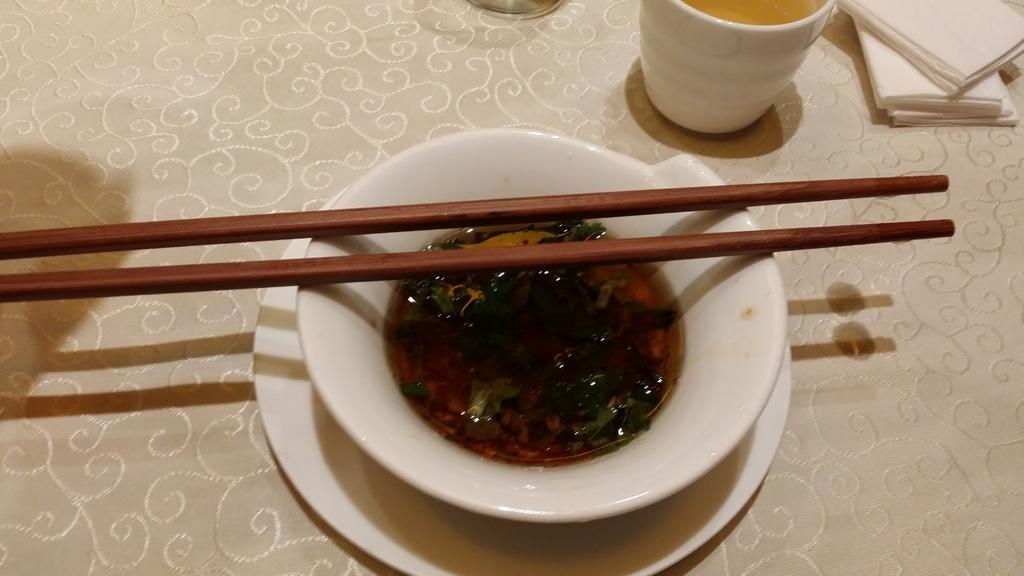What is in the bowl that is visible in the image? There is a bowl filled with a soul in the image. What utensil is placed with the bowl? Chopsticks are placed on the bowl. What other object is beside the bowl? There is a glass beside the bowl. On what is the bowl placed? The bowl is placed on a table. What type of sugar is being used to sweeten the soul in the image? There is no sugar present in the image, as it features a bowl filled with a soul and chopsticks on a table. 